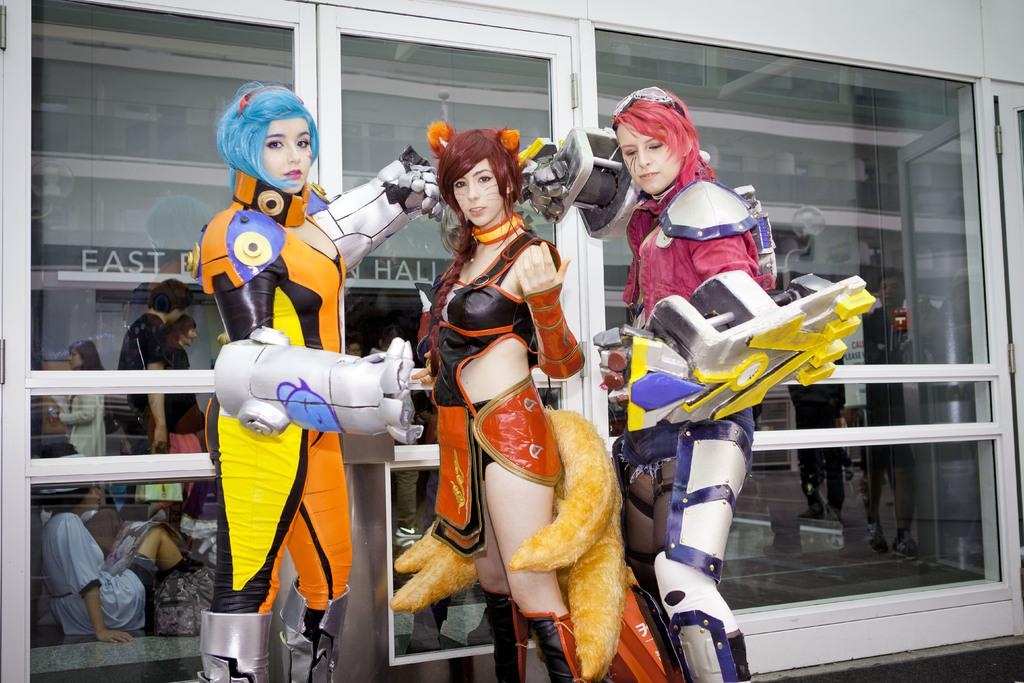How many people are in the image? There are three persons in the image. What are the persons wearing? The persons are wearing different costumes. What is the background of the image? There is a wall with glass in the image. What can be seen through the glass? Persons and text are visible through the glass. What type of offer is being made by the mother in the image? There is no mother or offer present in the image. How does the care provided by the persons in the image differ from one another? The image does not show any care being provided by the persons, only their costumes and the presence of a wall with glass. 